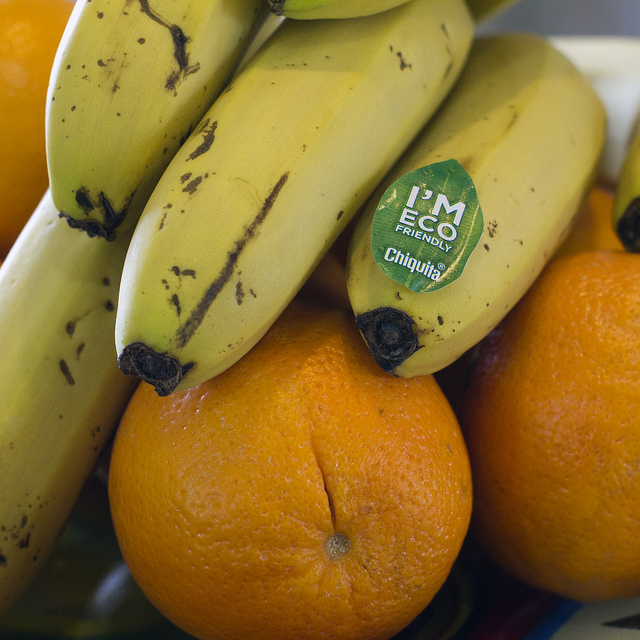Please identify all text content in this image. I'M ECO FRIENDELY Chiquita 